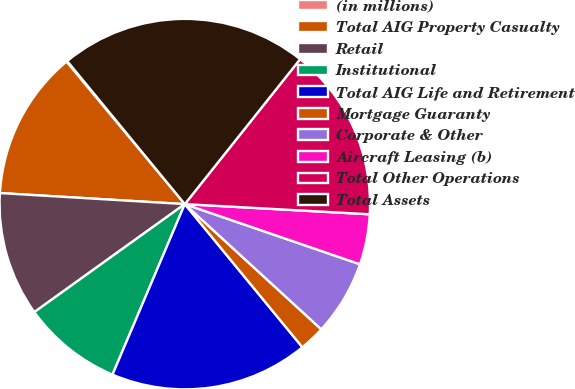Convert chart. <chart><loc_0><loc_0><loc_500><loc_500><pie_chart><fcel>(in millions)<fcel>Total AIG Property Casualty<fcel>Retail<fcel>Institutional<fcel>Total AIG Life and Retirement<fcel>Mortgage Guaranty<fcel>Corporate & Other<fcel>Aircraft Leasing (b)<fcel>Total Other Operations<fcel>Total Assets<nl><fcel>0.08%<fcel>13.02%<fcel>10.86%<fcel>8.71%<fcel>17.33%<fcel>2.24%<fcel>6.55%<fcel>4.39%<fcel>15.18%<fcel>21.65%<nl></chart> 